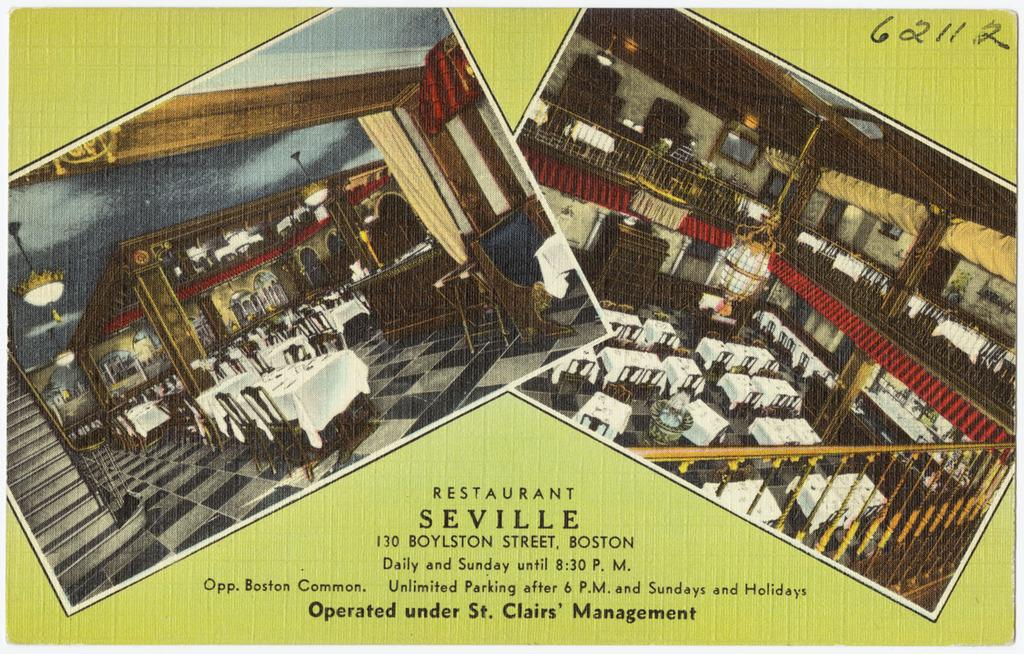<image>
Provide a brief description of the given image. An old postcard from the Restaurant Seville in Boston has the address and hours of the restaurant. 